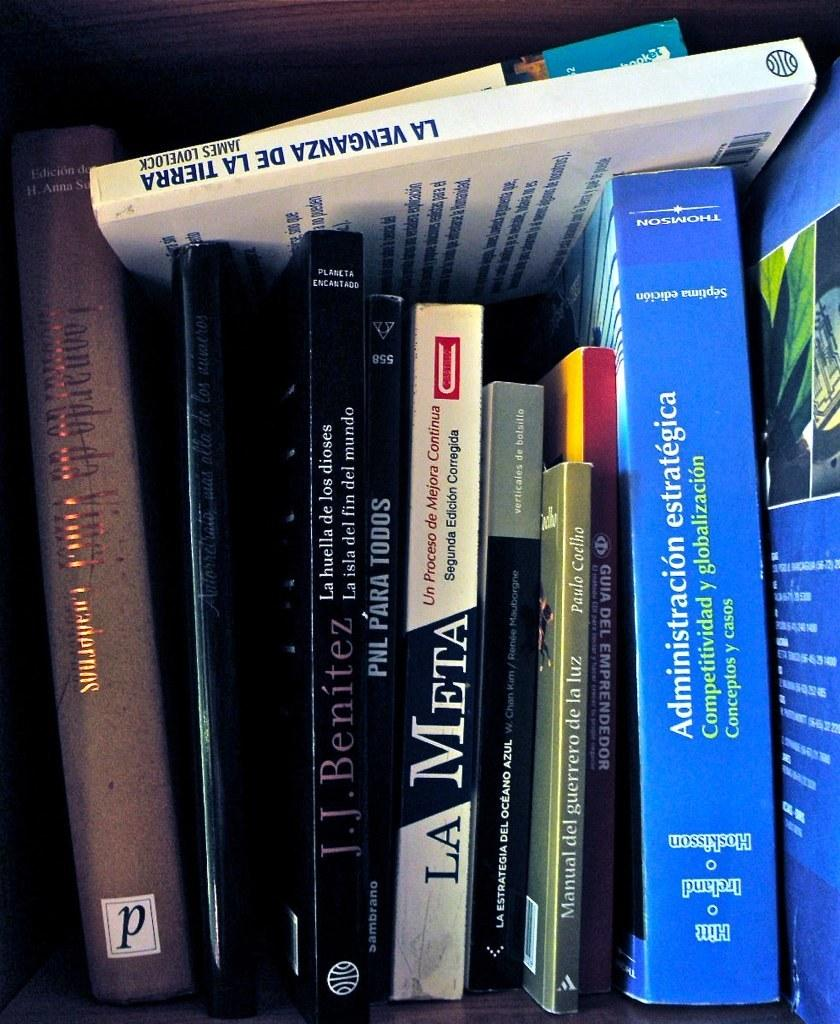<image>
Present a compact description of the photo's key features. LA META is the 5th book from the left. 